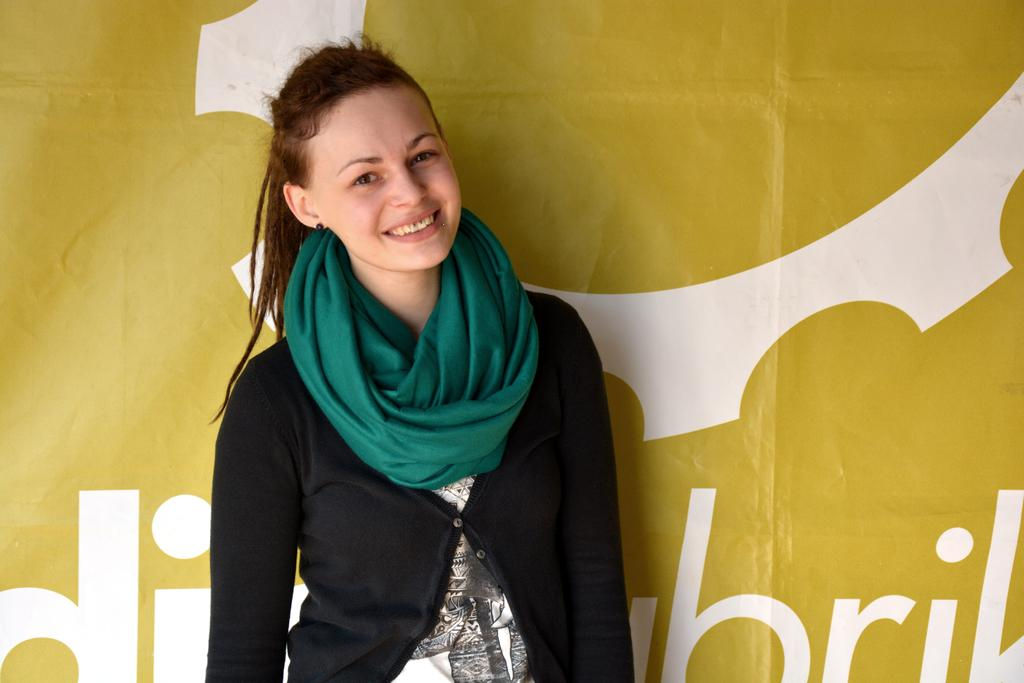What is the main subject of the image? There is a girl standing in the middle of the image. How is the girl's expression in the image? The girl has a smiling face. What can be seen in the background of the image? There is a banner in the background of the image. What is written on the banner? The banner has text on it. Can you see any birds perched on the girl's shoulder in the image? There are no birds present in the image. Is the girl lying on a bed in the image? The girl is standing, not lying on a bed, in the image. 